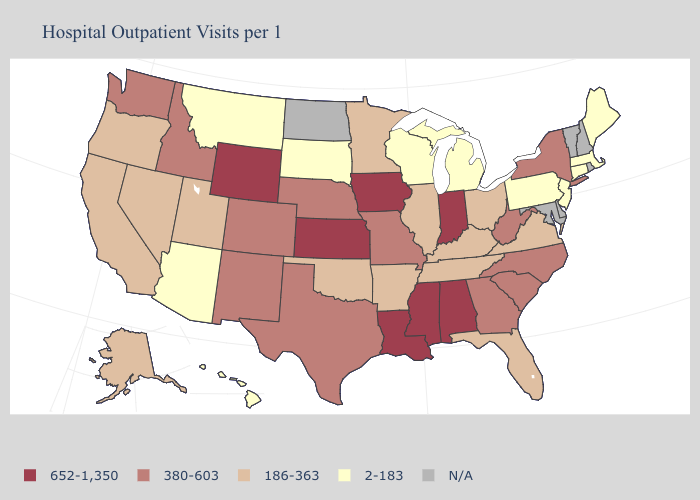What is the lowest value in states that border Massachusetts?
Quick response, please. 2-183. What is the highest value in states that border Minnesota?
Write a very short answer. 652-1,350. Which states have the lowest value in the USA?
Quick response, please. Arizona, Connecticut, Hawaii, Maine, Massachusetts, Michigan, Montana, New Jersey, Pennsylvania, South Dakota, Wisconsin. Which states hav the highest value in the MidWest?
Quick response, please. Indiana, Iowa, Kansas. Name the states that have a value in the range N/A?
Be succinct. Delaware, Maryland, New Hampshire, North Dakota, Rhode Island, Vermont. What is the highest value in the West ?
Write a very short answer. 652-1,350. What is the value of Idaho?
Concise answer only. 380-603. Name the states that have a value in the range 380-603?
Give a very brief answer. Colorado, Georgia, Idaho, Missouri, Nebraska, New Mexico, New York, North Carolina, South Carolina, Texas, Washington, West Virginia. Which states have the lowest value in the West?
Keep it brief. Arizona, Hawaii, Montana. Name the states that have a value in the range N/A?
Write a very short answer. Delaware, Maryland, New Hampshire, North Dakota, Rhode Island, Vermont. Does Kansas have the highest value in the MidWest?
Answer briefly. Yes. Which states have the lowest value in the Northeast?
Be succinct. Connecticut, Maine, Massachusetts, New Jersey, Pennsylvania. What is the value of Florida?
Write a very short answer. 186-363. 